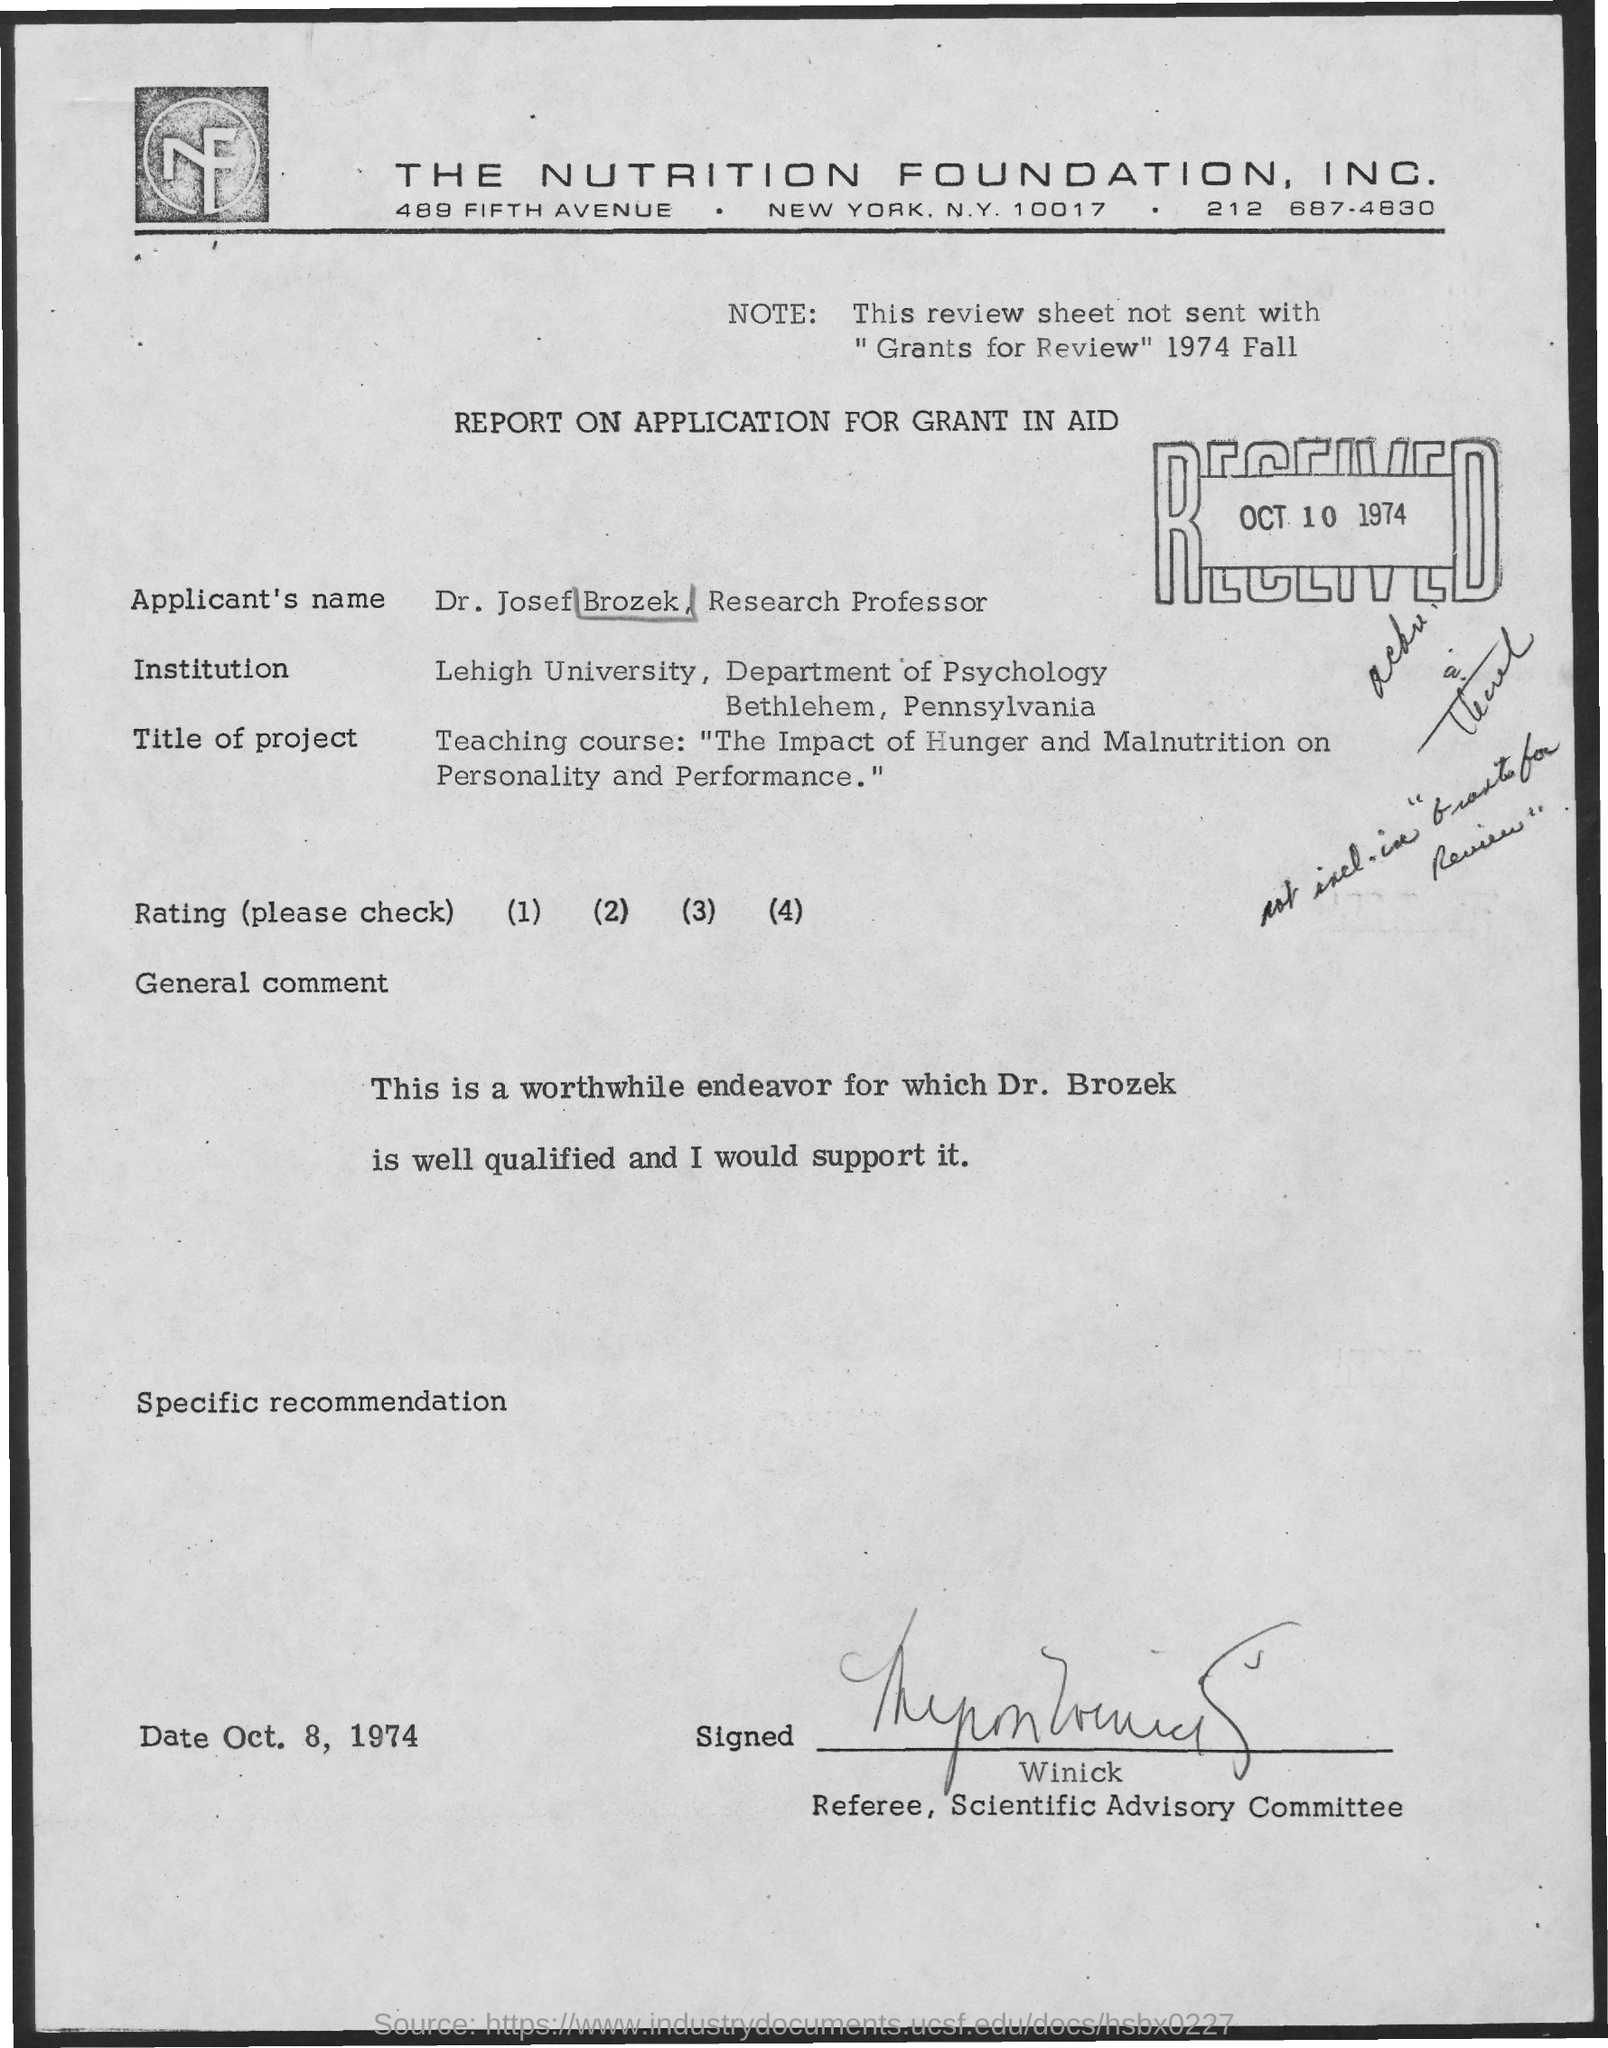What is the date mentioned on the right side of report?
Ensure brevity in your answer.  Oct 10 1974. What is the note written?
Keep it short and to the point. This review sheet not sent with "Grants for Review" 1974 Fall. 